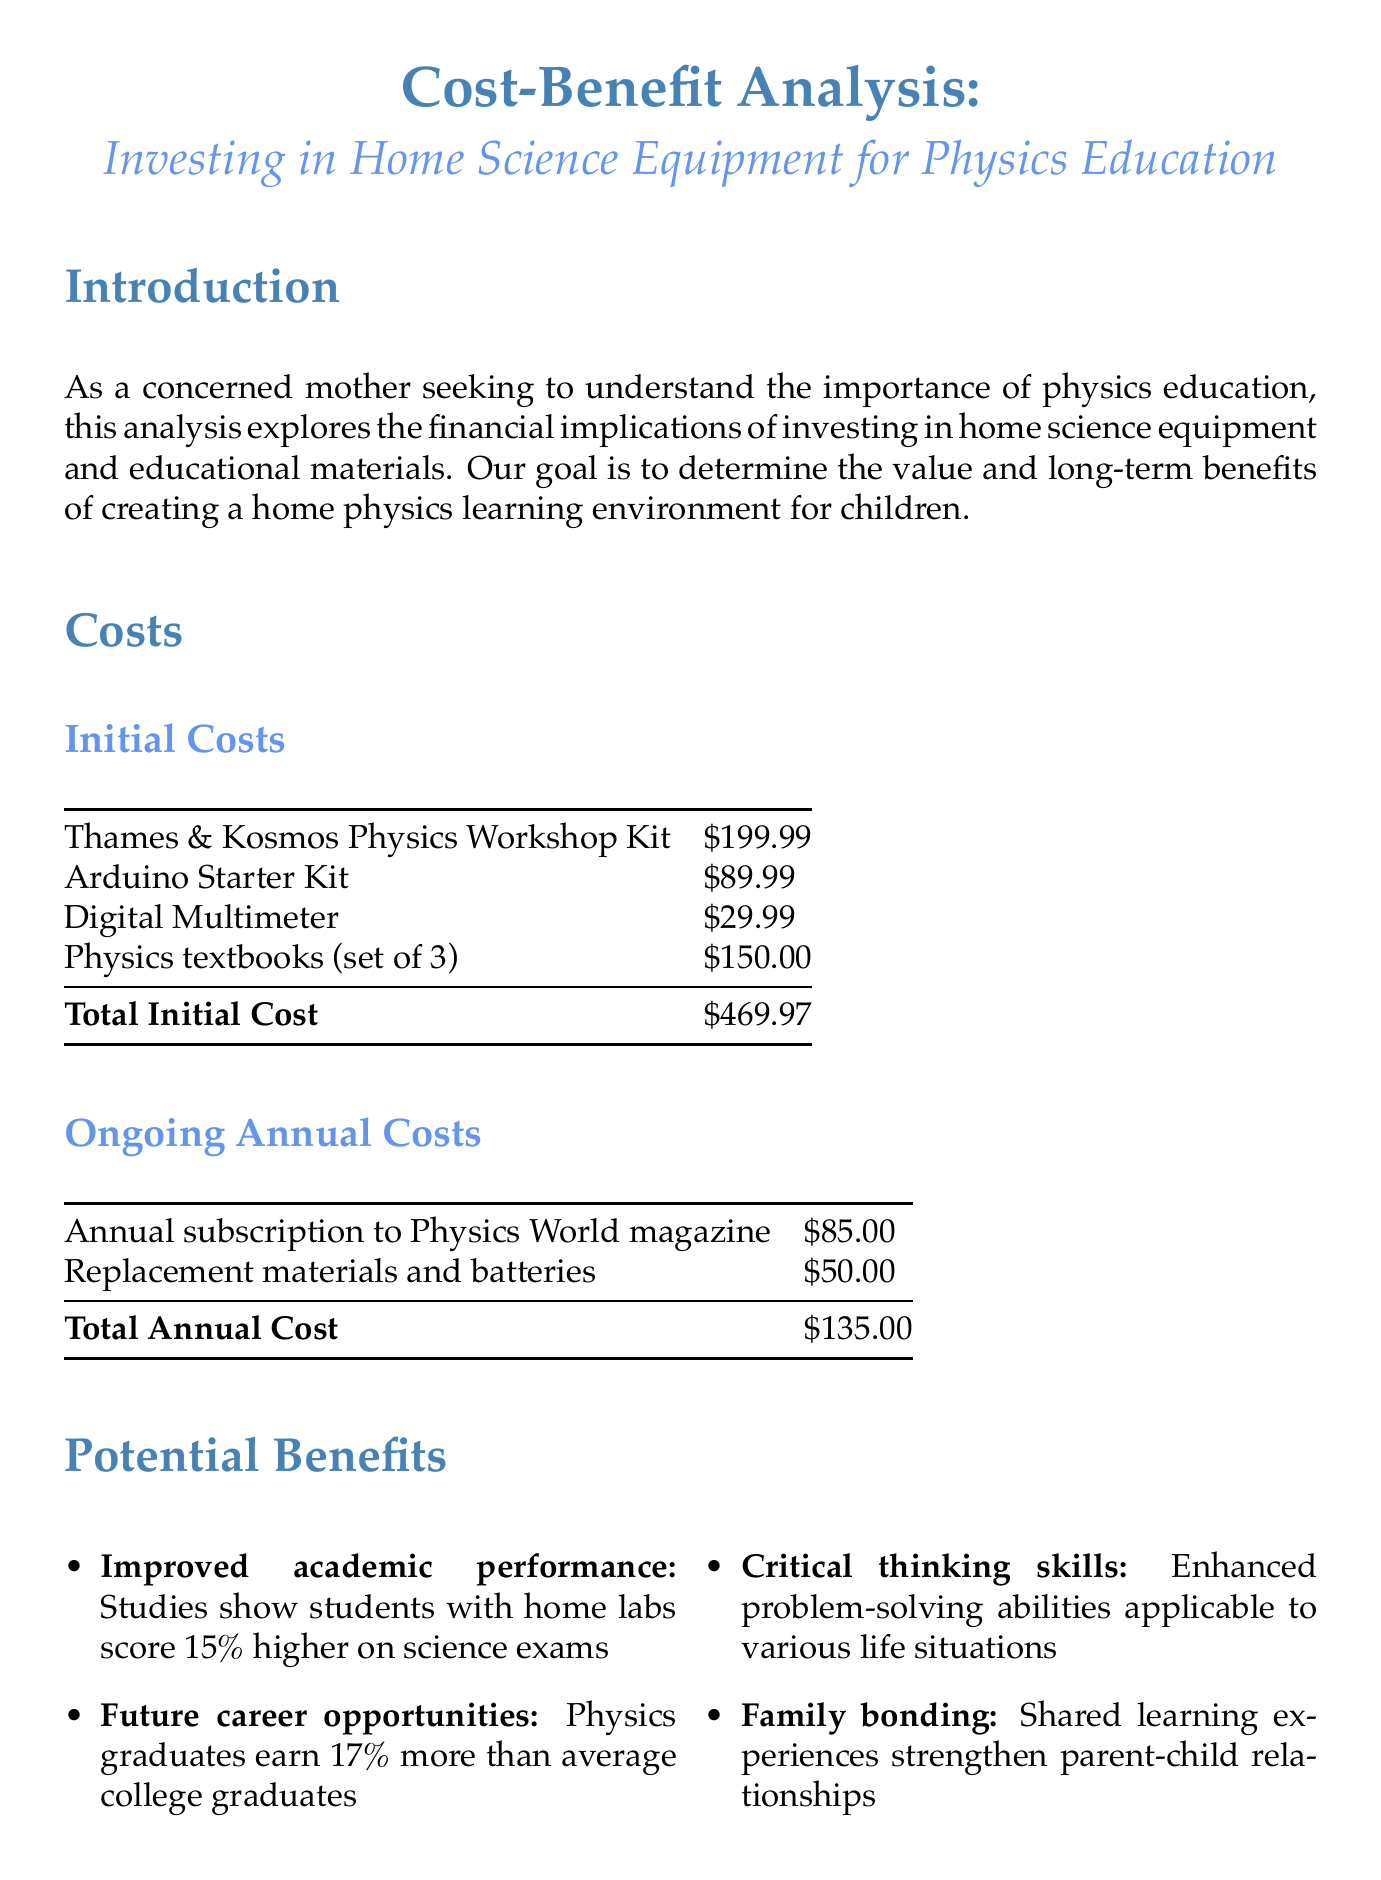What is the title of the report? The title is the first line of the document, summarizing the focus on cost-benefit analysis related to physics education.
Answer: Cost-Benefit Analysis: Investing in Home Science Equipment for Physics Education What is the total initial cost of the equipment? The total initial cost is calculated by adding up all listed initial costs.
Answer: $469.97 How much can be saved on private tutoring per year? The document mentions the savings that can be achieved by reducing the need for private tutoring.
Answer: Up to $1,200 per year What percentage do students with home labs score higher on science exams? The report indicates the improvement in exam scores for students engaged in home lab activities.
Answer: 15% What is one benefit of investing in home science equipment mentioned in the report? The document lists several benefits, among which one is highlighted.
Answer: Improved academic performance What is the average scholarship opportunity for physics students? Information regarding scholarships is noted in the long-term savings section of the document.
Answer: $5,000 per year What is one of the goals of this cost-benefit analysis? The purpose of the analysis is stated in the introduction, focusing on educational benefits.
Answer: To determine the value and long-term benefits What is the recommended action for parents considering this investment? The conclusion emphasizes the recommendation to parents based on analysis findings.
Answer: Proceed with the investment 